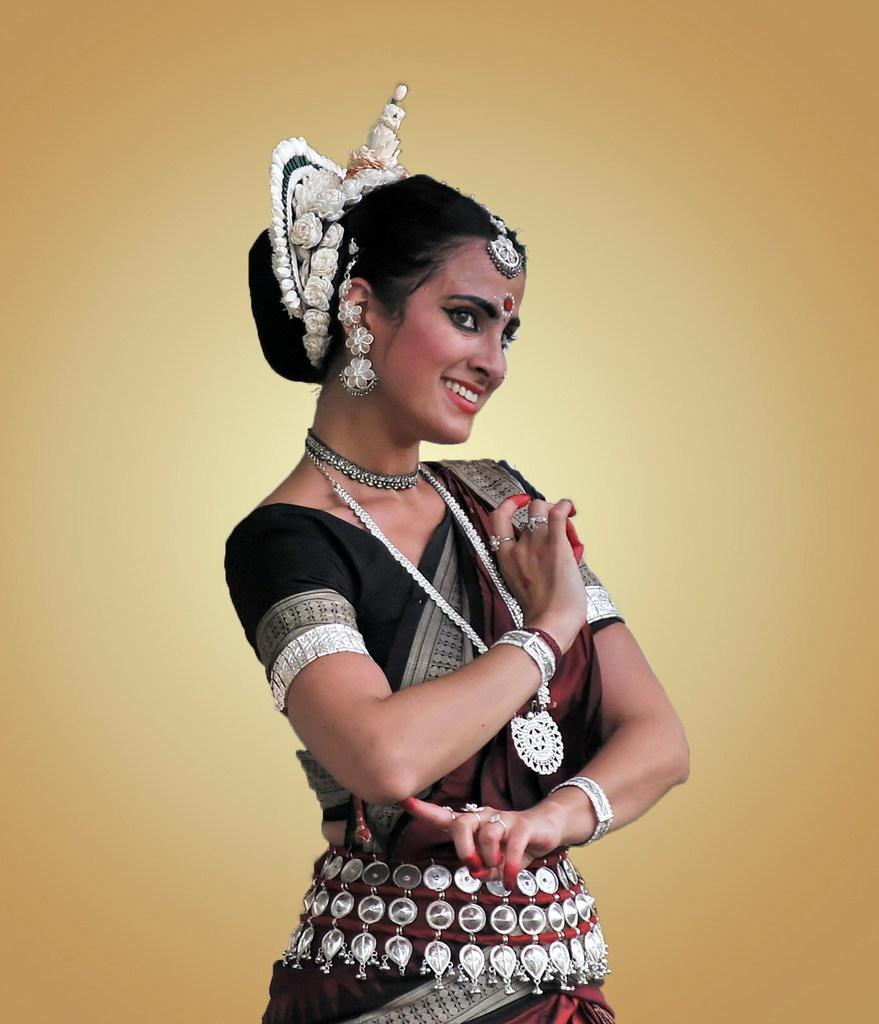Who is the main subject in the image? There is a woman in the image. What is the woman wearing? The woman is wearing a black dress and a necklace. What expression does the woman have? The woman is smiling. What is the color of the background in the image? The background of the image is in cream color. What type of sense can be seen in the image? There is no sense present in the image; it features a woman wearing a black dress, a necklace, and smiling. Can you tell me how many tramps are visible in the image? There are no tramps present in the image. 